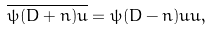<formula> <loc_0><loc_0><loc_500><loc_500>\overline { \psi ( D + n ) u } = \psi ( D - n ) u u ,</formula> 